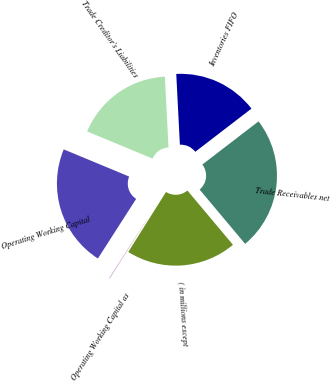Convert chart. <chart><loc_0><loc_0><loc_500><loc_500><pie_chart><fcel>( in millions except<fcel>Trade Receivables net<fcel>Inventories FIFO<fcel>Trade Creditor's Liabilities<fcel>Operating Working Capital<fcel>Operating Working Capital as<nl><fcel>20.05%<fcel>24.32%<fcel>15.39%<fcel>17.92%<fcel>22.19%<fcel>0.14%<nl></chart> 